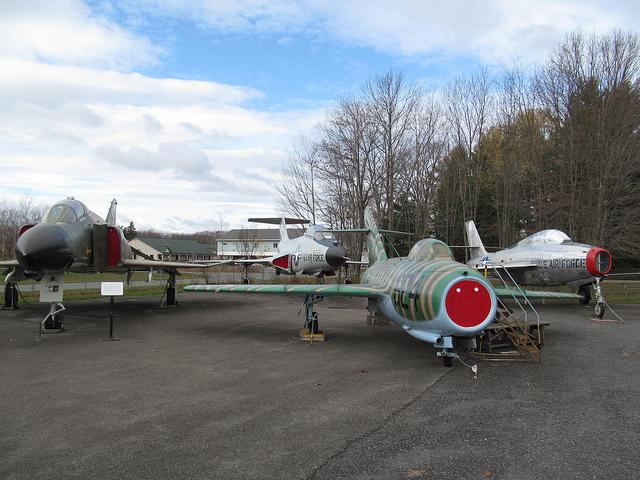The planes were likely used for what transportation purpose? military 